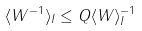Convert formula to latex. <formula><loc_0><loc_0><loc_500><loc_500>\langle W ^ { - 1 } \rangle _ { I } \leq Q \langle W \rangle _ { I } ^ { - 1 }</formula> 